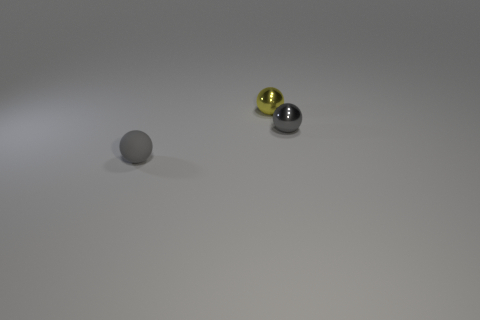What shape is the matte object that is the same size as the yellow ball?
Your response must be concise. Sphere. The ball that is the same material as the yellow thing is what color?
Your response must be concise. Gray. What material is the other gray object that is the same size as the gray metal object?
Your response must be concise. Rubber. Is there a big matte cylinder of the same color as the rubber sphere?
Keep it short and to the point. No. What shape is the small object that is both on the right side of the tiny rubber ball and in front of the yellow metallic sphere?
Ensure brevity in your answer.  Sphere. How many tiny green cubes have the same material as the yellow thing?
Provide a short and direct response. 0. Are there fewer gray things that are in front of the gray metallic sphere than objects in front of the small yellow thing?
Keep it short and to the point. Yes. What material is the ball to the left of the small metal object that is left of the tiny gray sphere behind the tiny gray rubber object made of?
Offer a terse response. Rubber. There is a object that is left of the tiny gray metal thing and behind the matte object; what size is it?
Your answer should be very brief. Small. What number of cylinders are either small gray shiny objects or small metal things?
Ensure brevity in your answer.  0. 